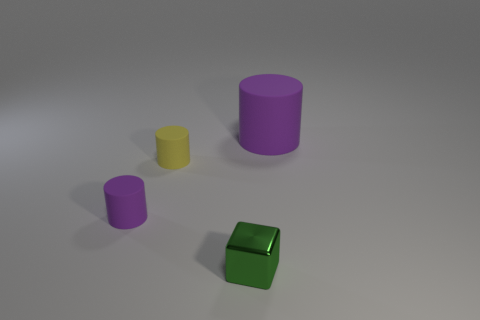Subtract all blue blocks. How many purple cylinders are left? 2 Subtract all small matte cylinders. How many cylinders are left? 1 Add 3 matte cylinders. How many objects exist? 7 Subtract all cylinders. How many objects are left? 1 Subtract all green cubes. Subtract all rubber cylinders. How many objects are left? 0 Add 4 metallic objects. How many metallic objects are left? 5 Add 1 big matte things. How many big matte things exist? 2 Subtract 0 brown blocks. How many objects are left? 4 